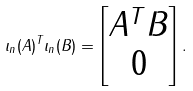Convert formula to latex. <formula><loc_0><loc_0><loc_500><loc_500>\iota _ { n } ( A ) ^ { T } \iota _ { n } ( B ) = \begin{bmatrix} A ^ { T } B \\ 0 \end{bmatrix} .</formula> 